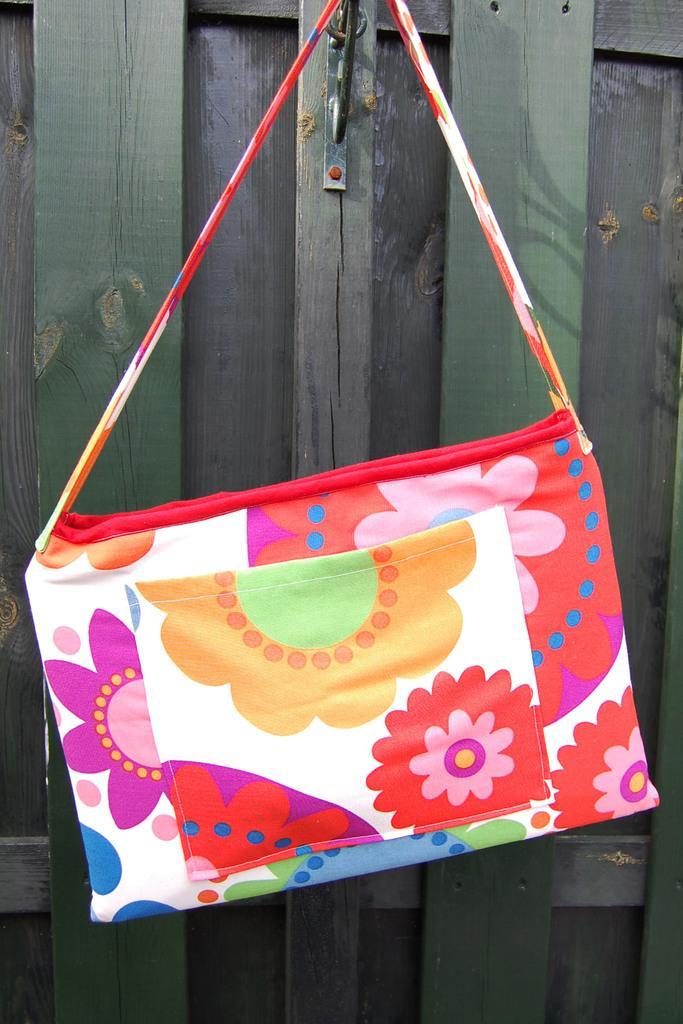Could you give a brief overview of what you see in this image? A colorful bag hangs on to a wall is shown in the picture. 